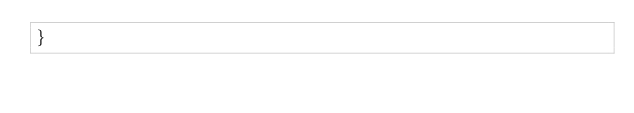<code> <loc_0><loc_0><loc_500><loc_500><_Kotlin_>}
</code> 